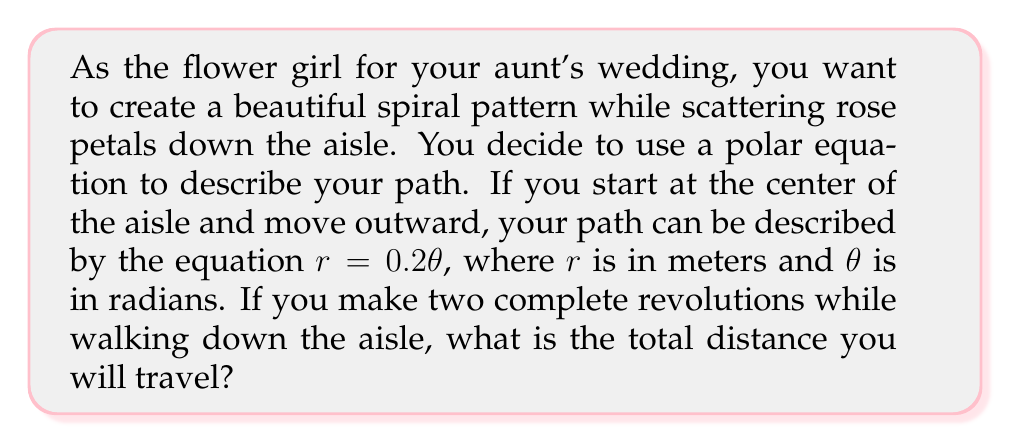Provide a solution to this math problem. To solve this problem, we need to follow these steps:

1) First, we need to determine the range of $\theta$ for two complete revolutions:
   Two revolutions = $4\pi$ radians

2) The path is described by a spiral, which in polar coordinates is given by $r = 0.2\theta$

3) To find the length of a curve in polar coordinates, we use the formula:

   $$L = \int_a^b \sqrt{r^2 + \left(\frac{dr}{d\theta}\right)^2} d\theta$$

4) In our case:
   $r = 0.2\theta$
   $\frac{dr}{d\theta} = 0.2$

5) Substituting into the formula:

   $$L = \int_0^{4\pi} \sqrt{(0.2\theta)^2 + 0.2^2} d\theta$$

6) Simplify under the square root:

   $$L = \int_0^{4\pi} \sqrt{0.04\theta^2 + 0.04} d\theta$$
   $$L = 0.2 \int_0^{4\pi} \sqrt{\theta^2 + 1} d\theta$$

7) This integral can be solved using the substitution $\theta = \sinh u$:

   $$L = 0.2 \left[ \frac{1}{2}(\theta\sqrt{\theta^2+1} + \ln|\theta + \sqrt{\theta^2+1}|) \right]_0^{4\pi}$$

8) Evaluating at the limits:

   $$L = 0.2 \left[ \frac{1}{2}(4\pi\sqrt{(4\pi)^2+1} + \ln|4\pi + \sqrt{(4\pi)^2+1}|) - 0 \right]$$

9) Calculating the final value:

   $$L \approx 5.03 \text{ meters}$$
Answer: The total distance traveled is approximately 5.03 meters. 